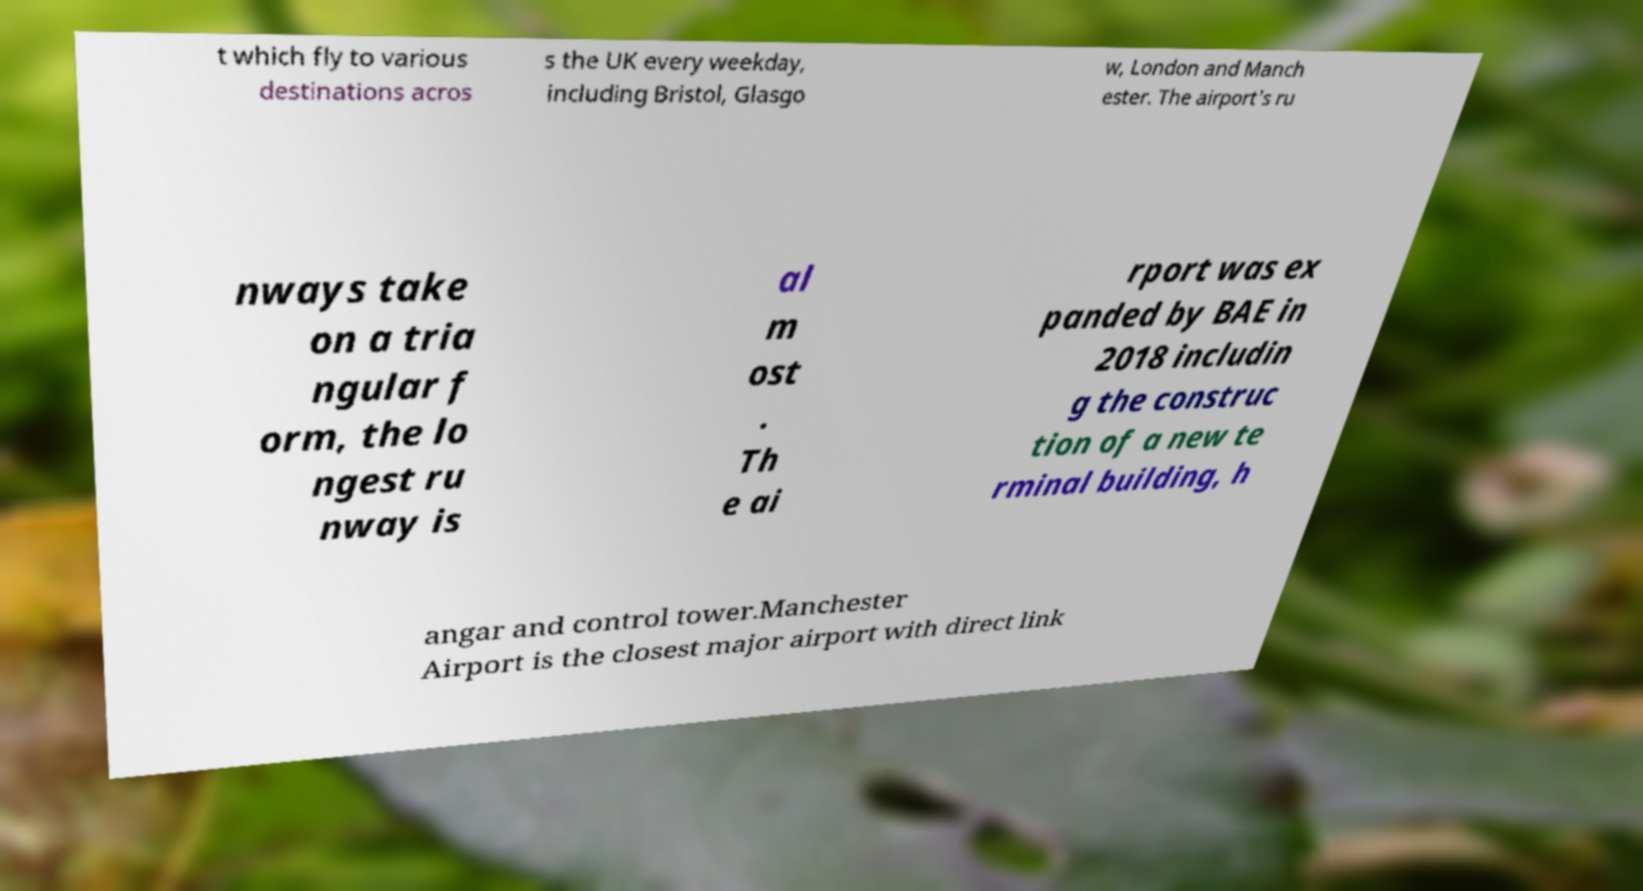Please identify and transcribe the text found in this image. t which fly to various destinations acros s the UK every weekday, including Bristol, Glasgo w, London and Manch ester. The airport's ru nways take on a tria ngular f orm, the lo ngest ru nway is al m ost . Th e ai rport was ex panded by BAE in 2018 includin g the construc tion of a new te rminal building, h angar and control tower.Manchester Airport is the closest major airport with direct link 